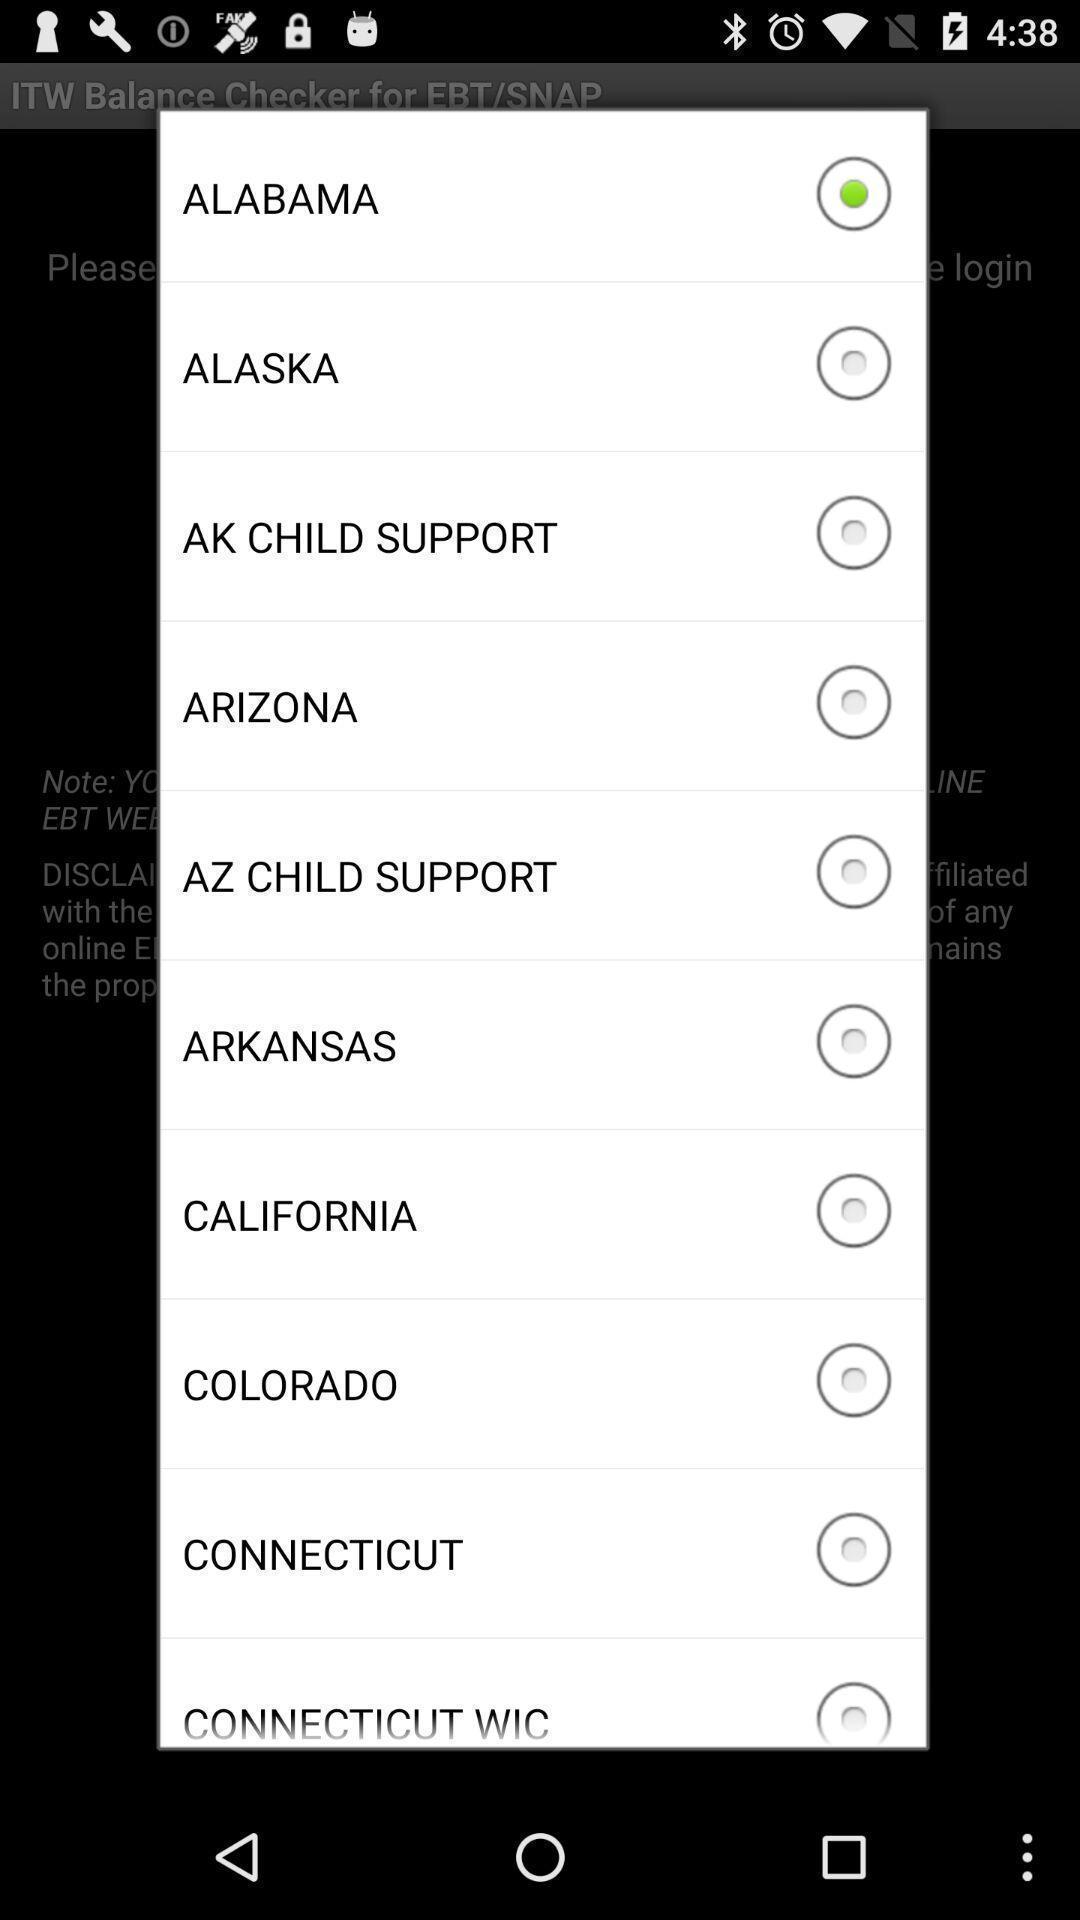Explain what's happening in this screen capture. Pop-up showing few country names. 